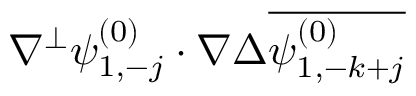Convert formula to latex. <formula><loc_0><loc_0><loc_500><loc_500>\nabla ^ { \perp } \psi _ { 1 , - j } ^ { ( 0 ) } \cdot \nabla \Delta \overline { { \psi _ { 1 , - k + j } ^ { ( 0 ) } } }</formula> 